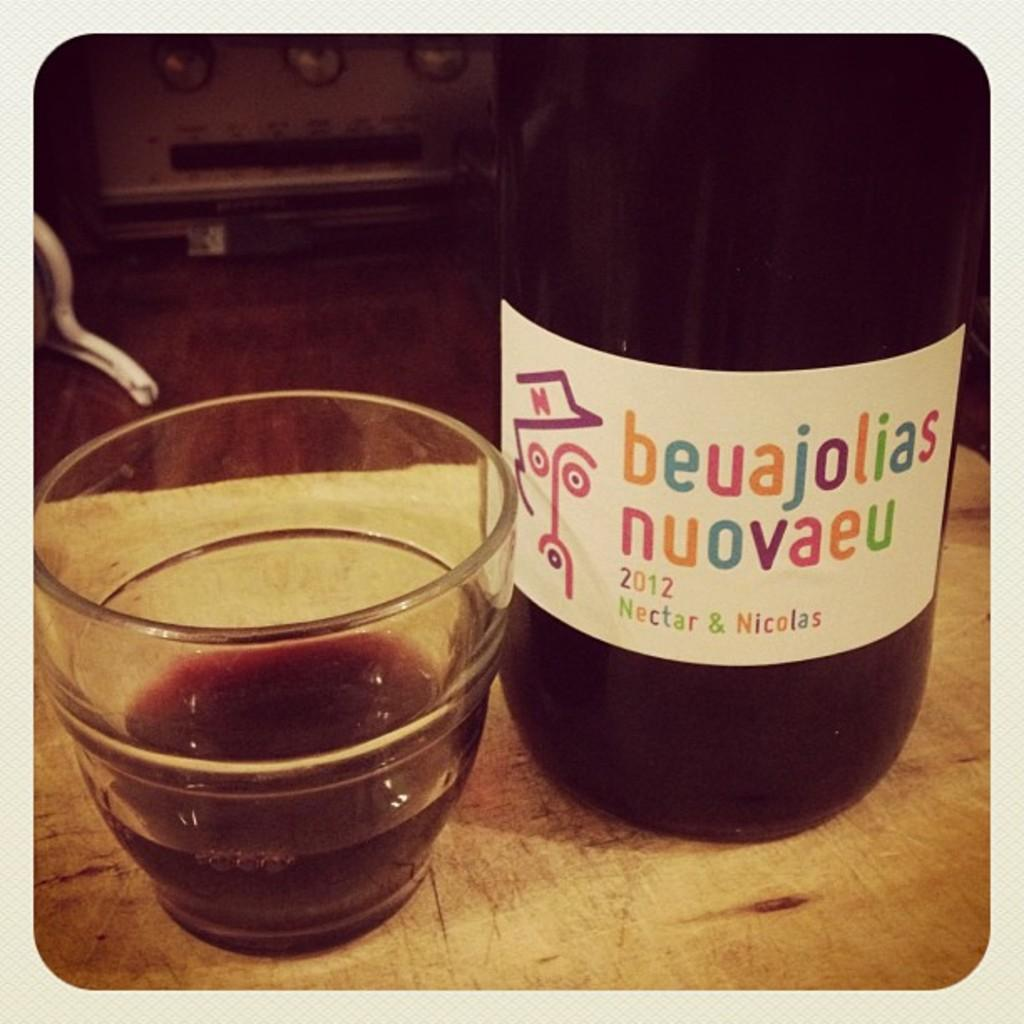<image>
Describe the image concisely. A glass sitting next to a bottle of beuajolias nuovaeu 2012. 